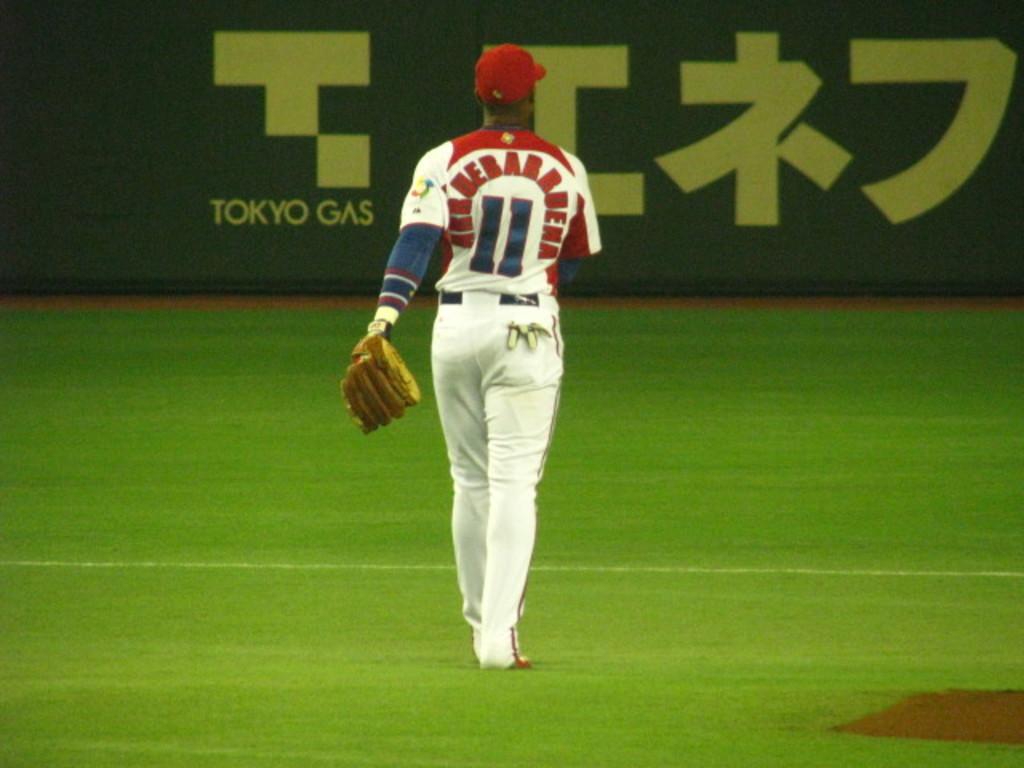What gas company is on the wall?
Provide a short and direct response. Tokyo gas. What is this player's number?
Offer a very short reply. 11. 